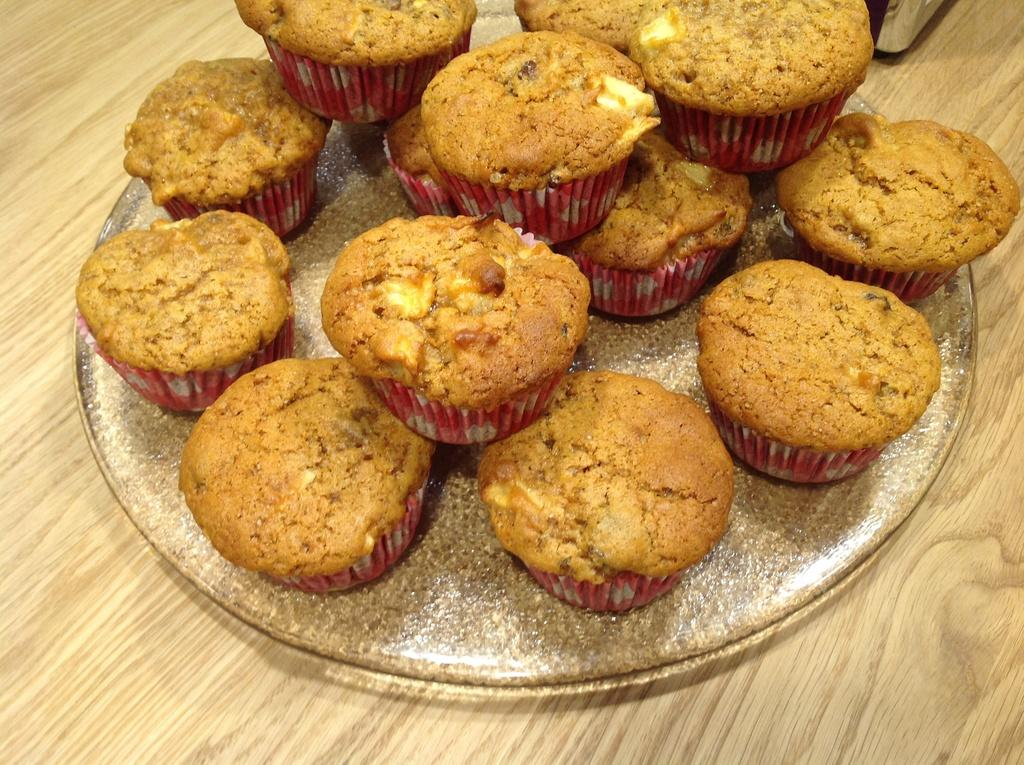What type of food is visible in the image? There are cupcakes in the image. How are the cupcakes arranged or placed in the image? The cupcakes are on a plate. Where is the plate with cupcakes located? The plate with cupcakes is on a table. What material is the table made of? The table is made of wood. What type of arithmetic problem is being solved on the desk in the image? There is no desk or arithmetic problem present in the image. What emotion is being expressed by the cupcakes in the image? Cupcakes do not express emotions; they are inanimate objects. 